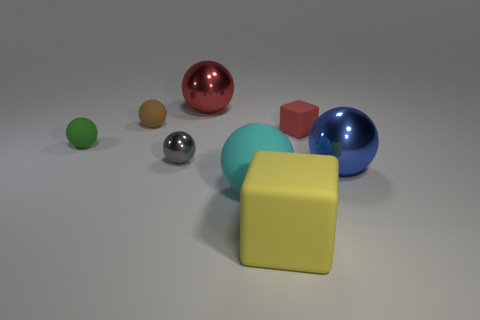How many objects are there, and can you describe their colors and shapes? There are seven objects in total, consisting of a large red sphere, a small orange sphere, a medium grayish sphere, a large blue sphere, a medium green sphere, a small brown sphere, and a red cube.  Which object stands out the most to you and why? The large red sphere stands out because of its vibrant color and prominent size relative to the other objects in the scene. 